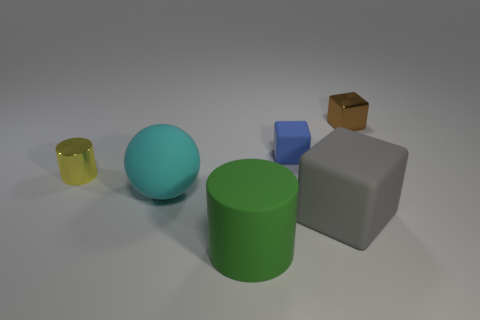Add 2 big yellow cylinders. How many objects exist? 8 Subtract all balls. How many objects are left? 5 Subtract all gray shiny cylinders. Subtract all rubber things. How many objects are left? 2 Add 1 big cyan objects. How many big cyan objects are left? 2 Add 6 small brown cubes. How many small brown cubes exist? 7 Subtract 0 purple blocks. How many objects are left? 6 